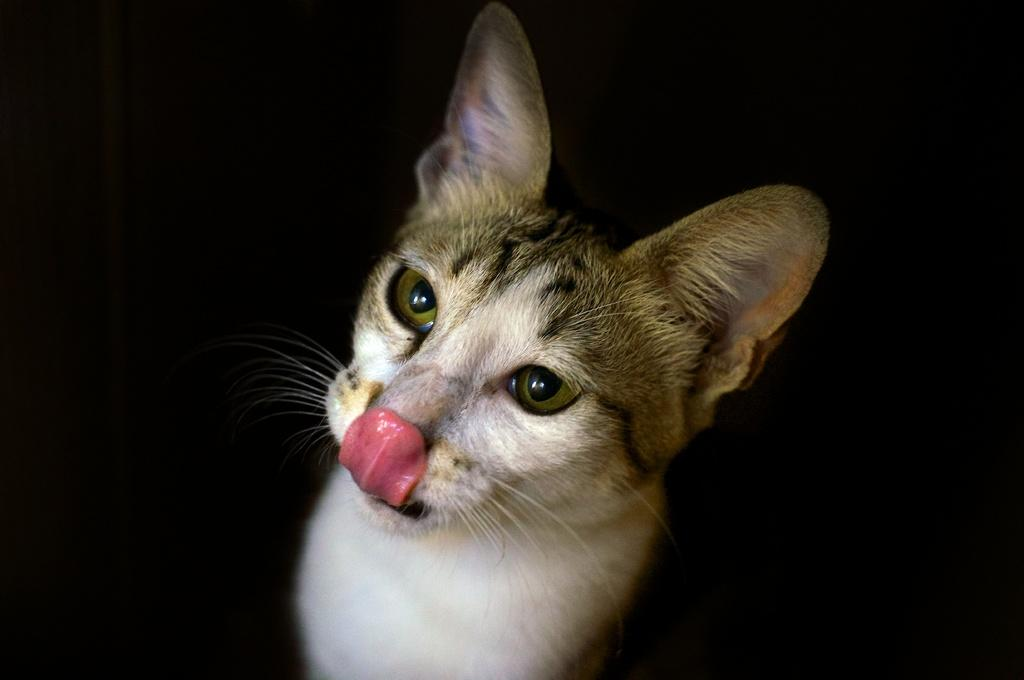What is the main subject of the image? There is a cat in the middle of the image. What color is the background of the image? The background of the image is black. What type of quartz can be seen in the image? There is no quartz present in the image; it features a cat in the middle of a black background. 